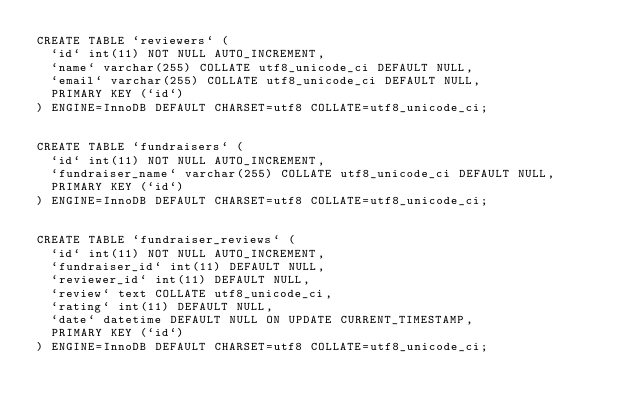<code> <loc_0><loc_0><loc_500><loc_500><_SQL_>CREATE TABLE `reviewers` (
  `id` int(11) NOT NULL AUTO_INCREMENT,
  `name` varchar(255) COLLATE utf8_unicode_ci DEFAULT NULL,
  `email` varchar(255) COLLATE utf8_unicode_ci DEFAULT NULL,
  PRIMARY KEY (`id`)
) ENGINE=InnoDB DEFAULT CHARSET=utf8 COLLATE=utf8_unicode_ci;


CREATE TABLE `fundraisers` (
  `id` int(11) NOT NULL AUTO_INCREMENT,
  `fundraiser_name` varchar(255) COLLATE utf8_unicode_ci DEFAULT NULL,
  PRIMARY KEY (`id`)
) ENGINE=InnoDB DEFAULT CHARSET=utf8 COLLATE=utf8_unicode_ci;


CREATE TABLE `fundraiser_reviews` (
  `id` int(11) NOT NULL AUTO_INCREMENT,
  `fundraiser_id` int(11) DEFAULT NULL,
  `reviewer_id` int(11) DEFAULT NULL,
  `review` text COLLATE utf8_unicode_ci,
  `rating` int(11) DEFAULT NULL,
  `date` datetime DEFAULT NULL ON UPDATE CURRENT_TIMESTAMP,
  PRIMARY KEY (`id`)
) ENGINE=InnoDB DEFAULT CHARSET=utf8 COLLATE=utf8_unicode_ci;

</code> 